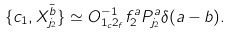<formula> <loc_0><loc_0><loc_500><loc_500>\{ c _ { 1 } , X _ { j _ { 2 } } ^ { \bar { b } } \} \simeq O _ { 1 _ { c } 2 _ { f } } ^ { - 1 } f _ { 2 } ^ { a } P _ { j _ { 2 } } ^ { a } \delta ( a - b ) .</formula> 